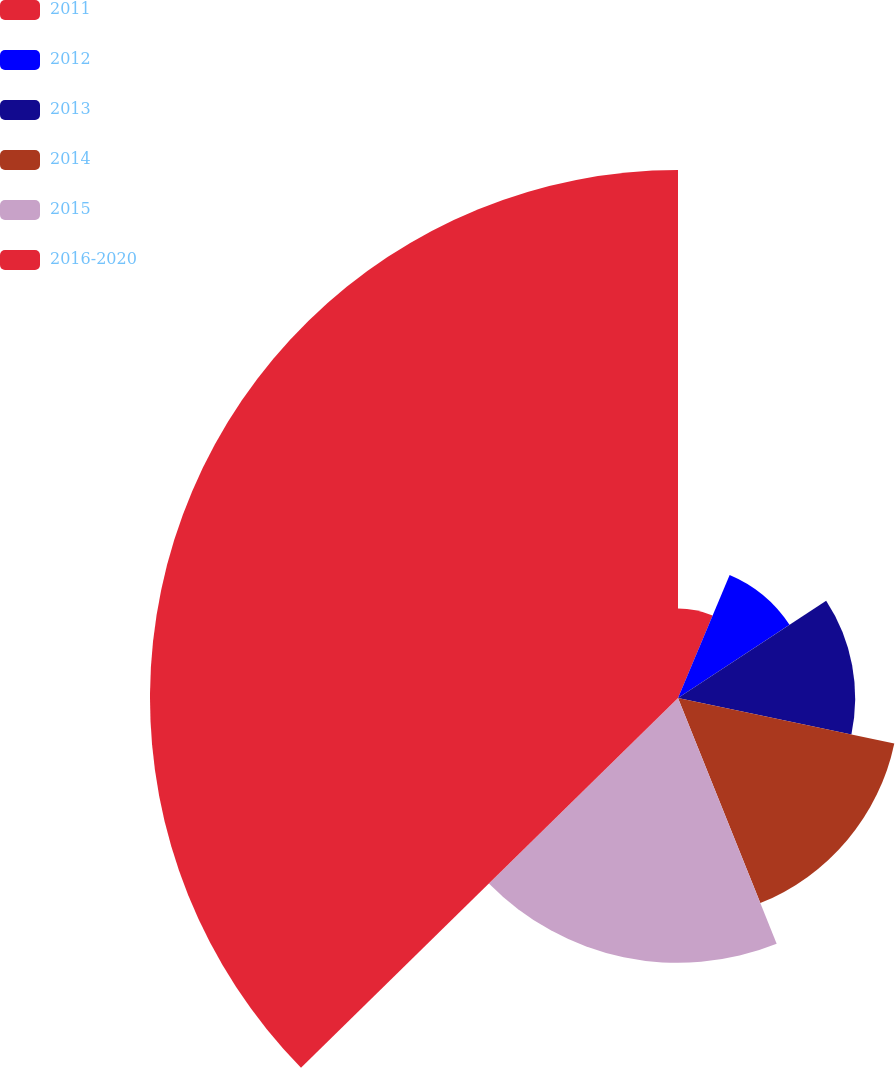Convert chart to OTSL. <chart><loc_0><loc_0><loc_500><loc_500><pie_chart><fcel>2011<fcel>2012<fcel>2013<fcel>2014<fcel>2015<fcel>2016-2020<nl><fcel>6.33%<fcel>9.43%<fcel>12.53%<fcel>15.63%<fcel>18.73%<fcel>37.34%<nl></chart> 